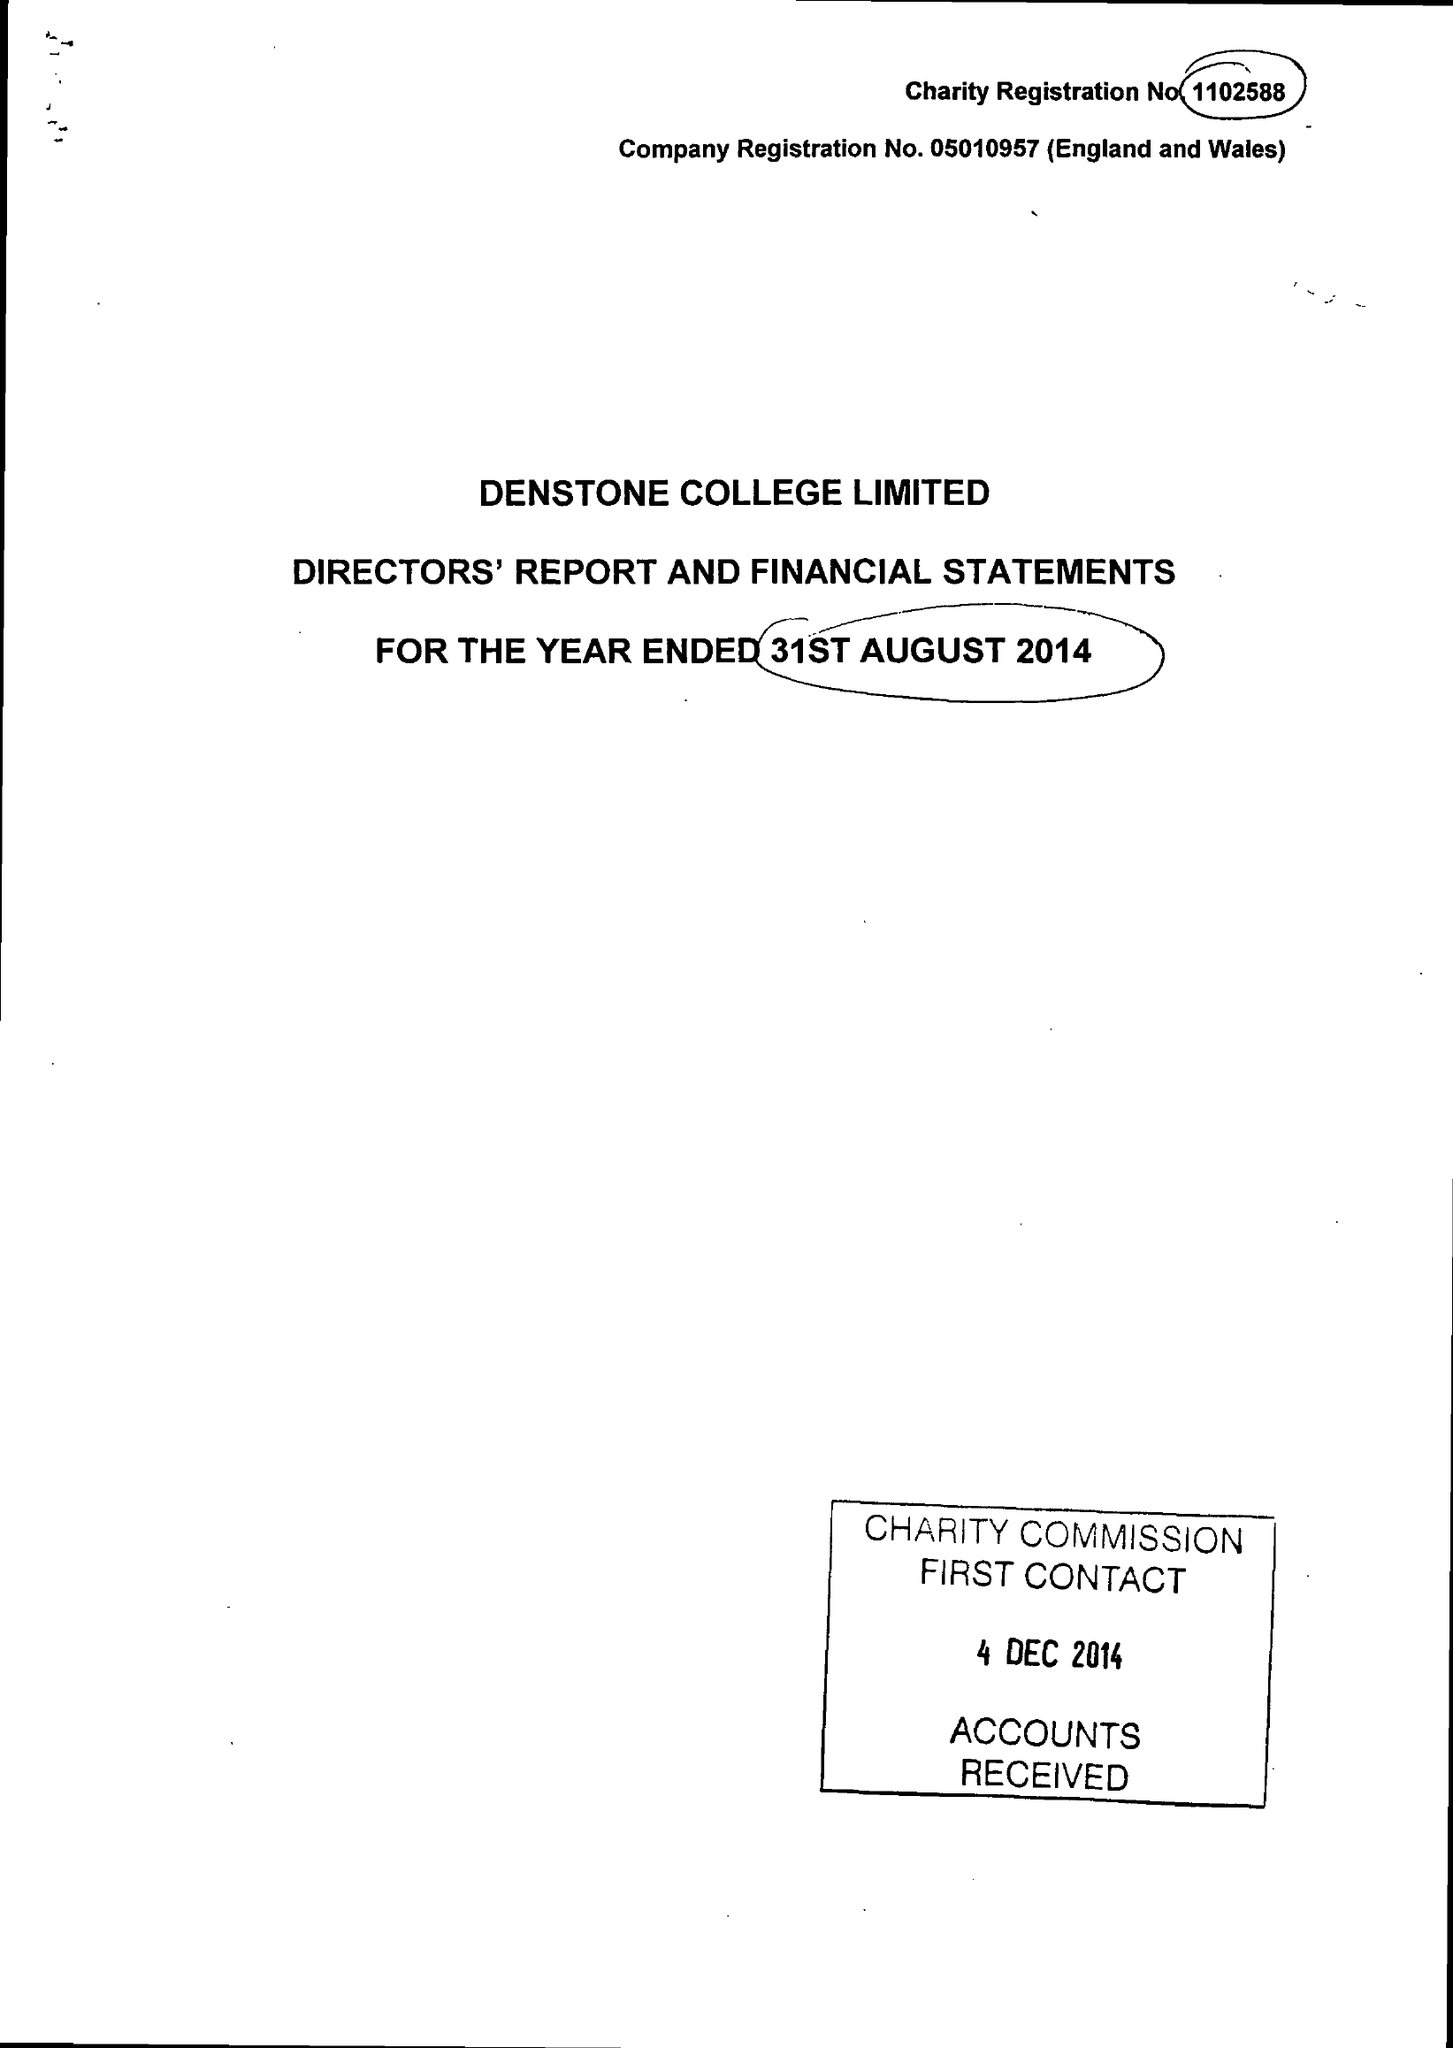What is the value for the charity_number?
Answer the question using a single word or phrase. 1102588 